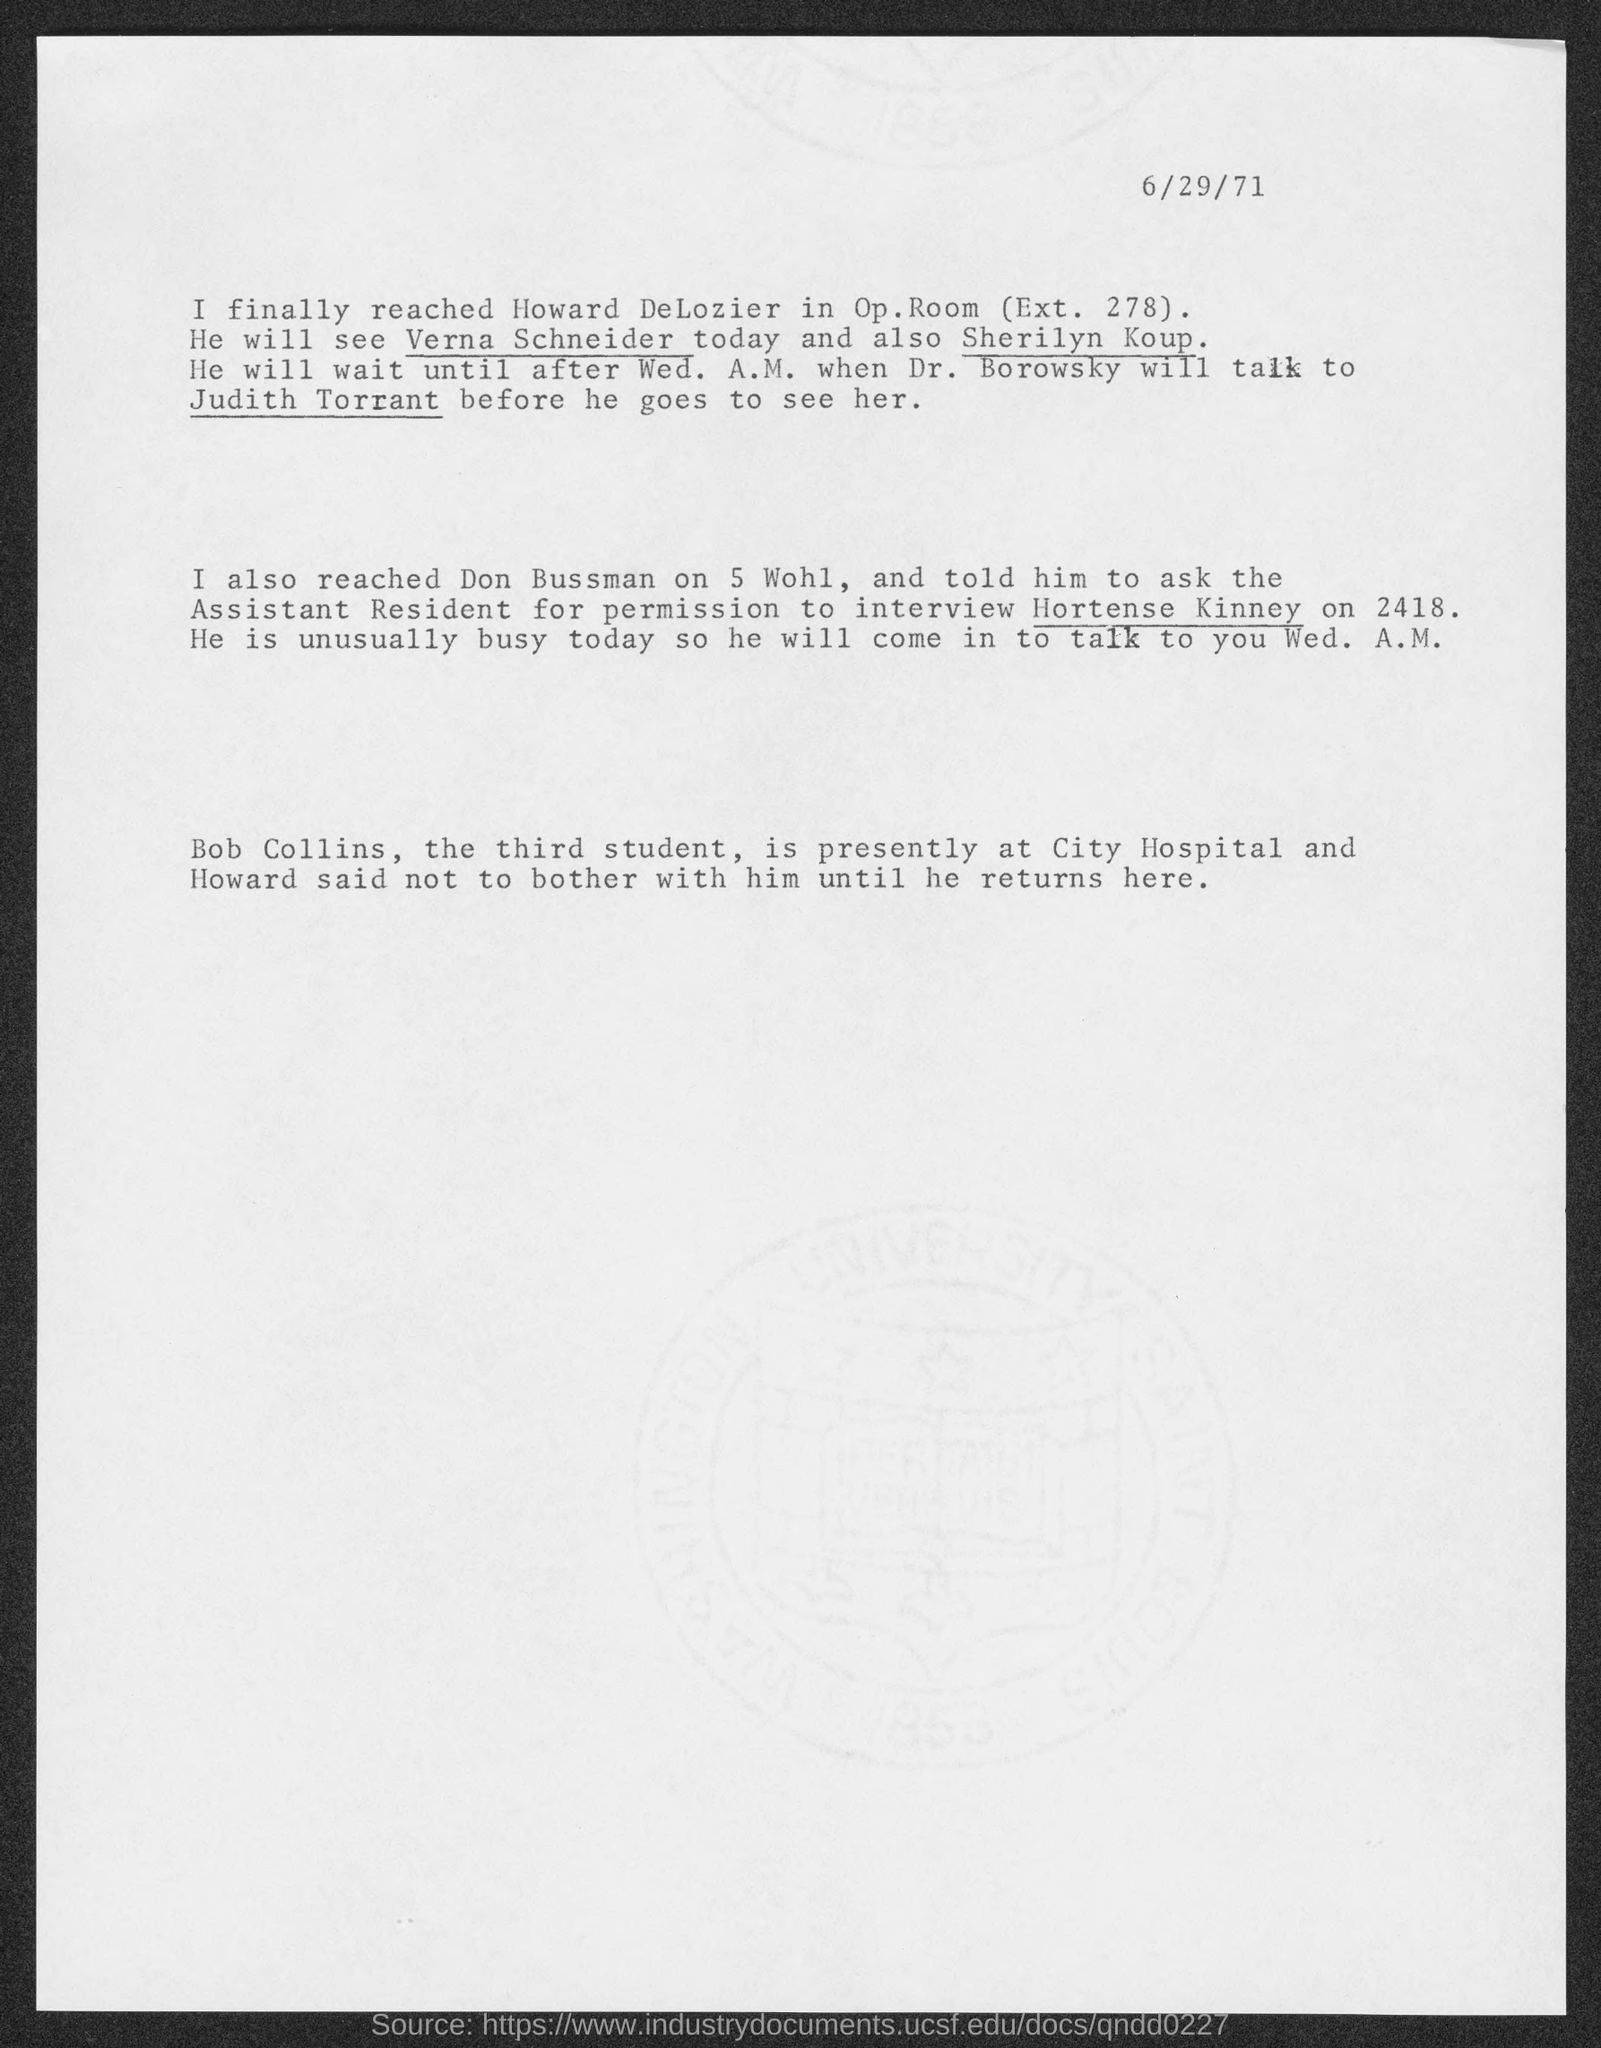What is the date at top-right of the page?
Offer a terse response. 6/29/71. 